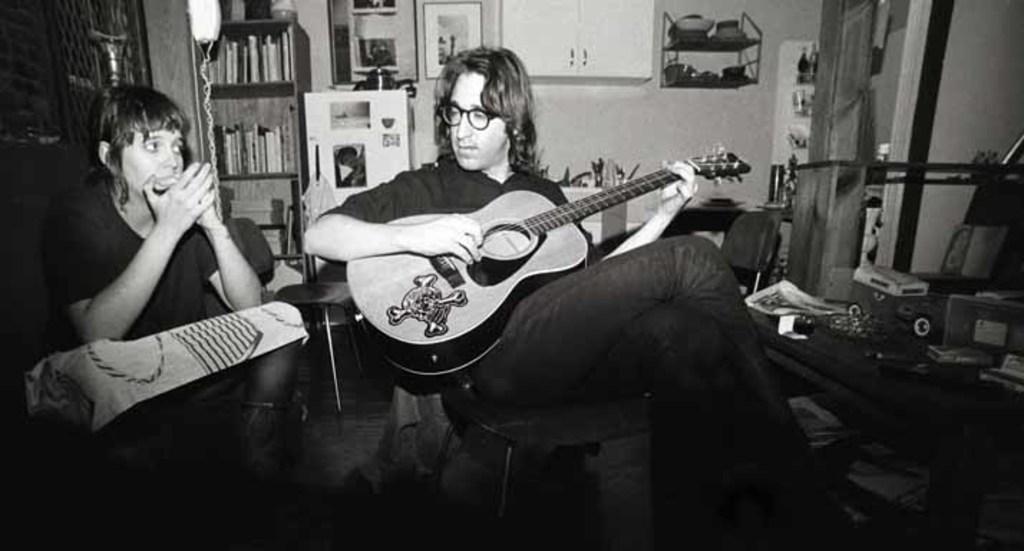Describe this image in one or two sentences. In this image i can see a man sitting on a chair and holding a guitar in his hand, to the left corner i can see a person sitting. In the background i can see bookshelf, a wall, a photo frame and a lamp. 